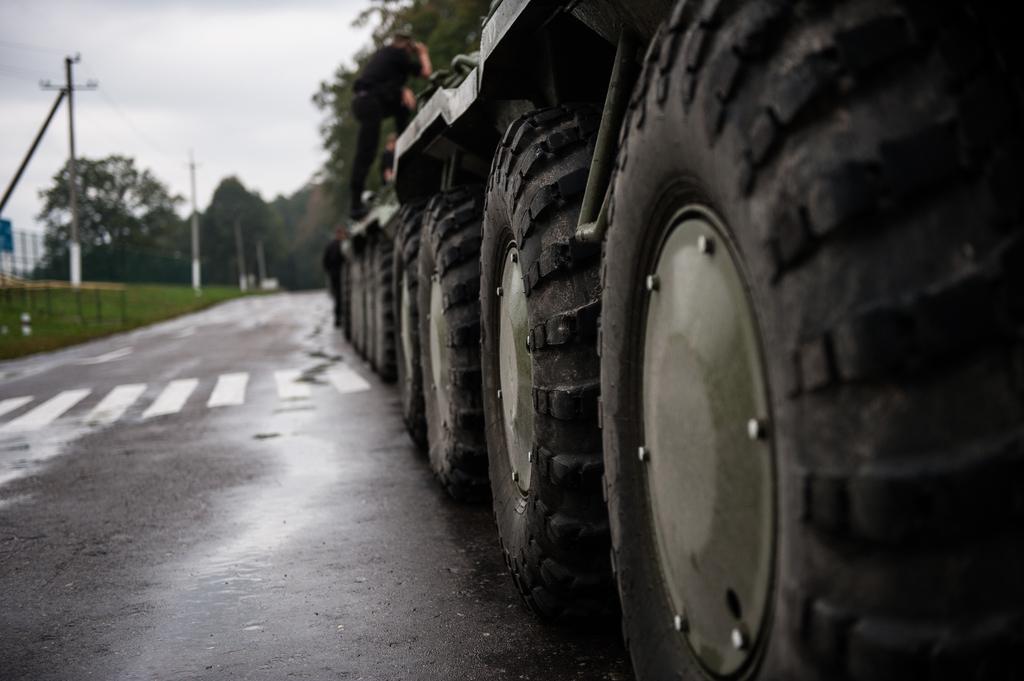Can you describe this image briefly? There is a road. On the right side we can see tires on a vehicle. There is a person on the vehicle. In the background there are electric poles ,trees and sky. And it is blurred in the background. 